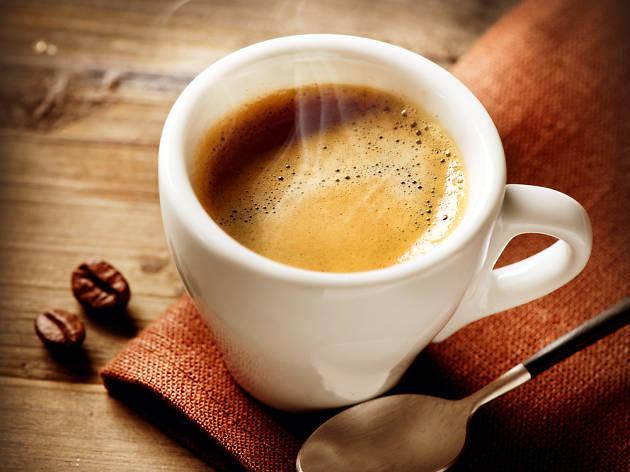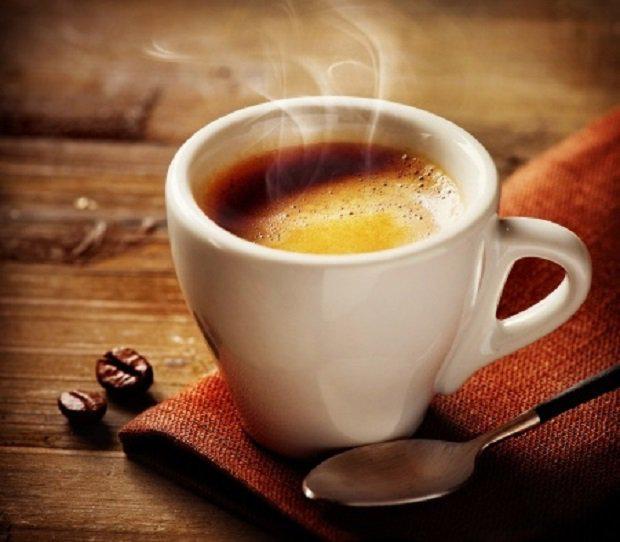The first image is the image on the left, the second image is the image on the right. Given the left and right images, does the statement "There are no more than two cups of coffee." hold true? Answer yes or no. Yes. The first image is the image on the left, the second image is the image on the right. Examine the images to the left and right. Is the description "There are three or more cups with coffee in them." accurate? Answer yes or no. No. 